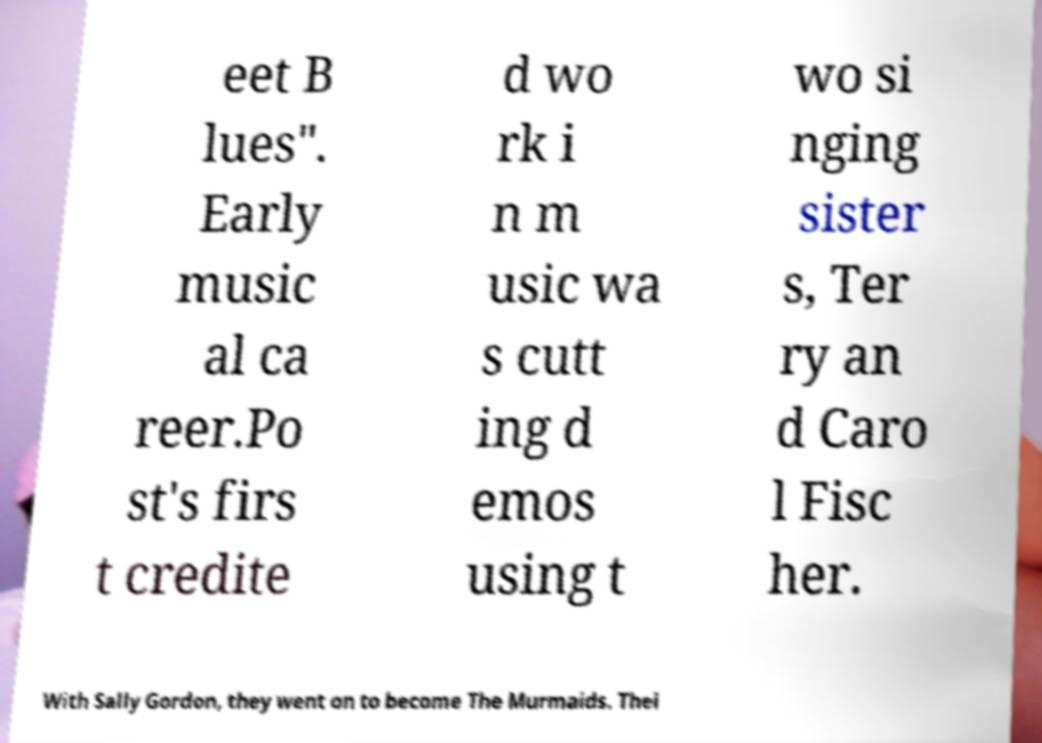Could you extract and type out the text from this image? eet B lues". Early music al ca reer.Po st's firs t credite d wo rk i n m usic wa s cutt ing d emos using t wo si nging sister s, Ter ry an d Caro l Fisc her. With Sally Gordon, they went on to become The Murmaids. Thei 